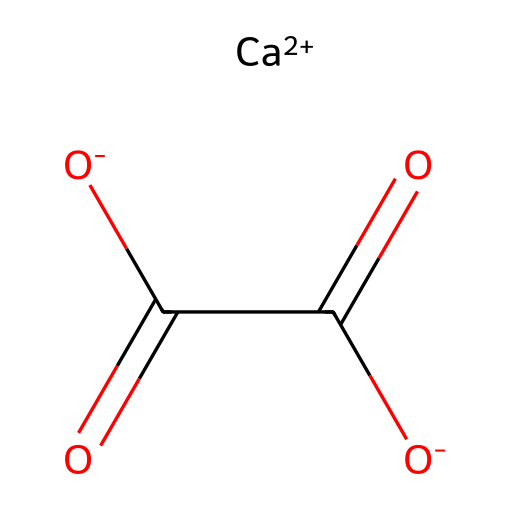What is the chemical name of the compound represented by the SMILES? The SMILES given corresponds to a compound that includes calcium (Ca) and oxalate ions, which is recognized as calcium oxalate.
Answer: calcium oxalate How many carbon atoms are in this compound? Analyzing the SMILES notation, there are two carbon atoms present in the oxalate part of the structure (each C appears once).
Answer: two What is the charge of calcium in this compound? The notation [Ca+2] indicates that calcium has a charge of +2, which is common in ionic compounds.
Answer: +2 What type of bond connects the carbon and oxygen in the oxalate groups? The SMILES shows C(=O), which indicates a double bond between carbon and oxygen. This is typical for carbonyl groups (C=O).
Answer: double bond How many oxygen atoms are present in this molecule? Analyzing the SMILES, there are four oxygen atoms in total: two in the oxalate structure and two that are negatively charged.
Answer: four What increases the solubility of calcium oxalate in water? The structure indicates that the ionic character from the [Ca+2] and the negative charges from the oxalate groups can interact with water, enhancing solubility.
Answer: ionic character What type of compound is calcium oxalate classified as? Given the presence of calcium ions and organic oxalate, it is classified as a salt, specifically an inorganic salt derived from organic acids.
Answer: salt 